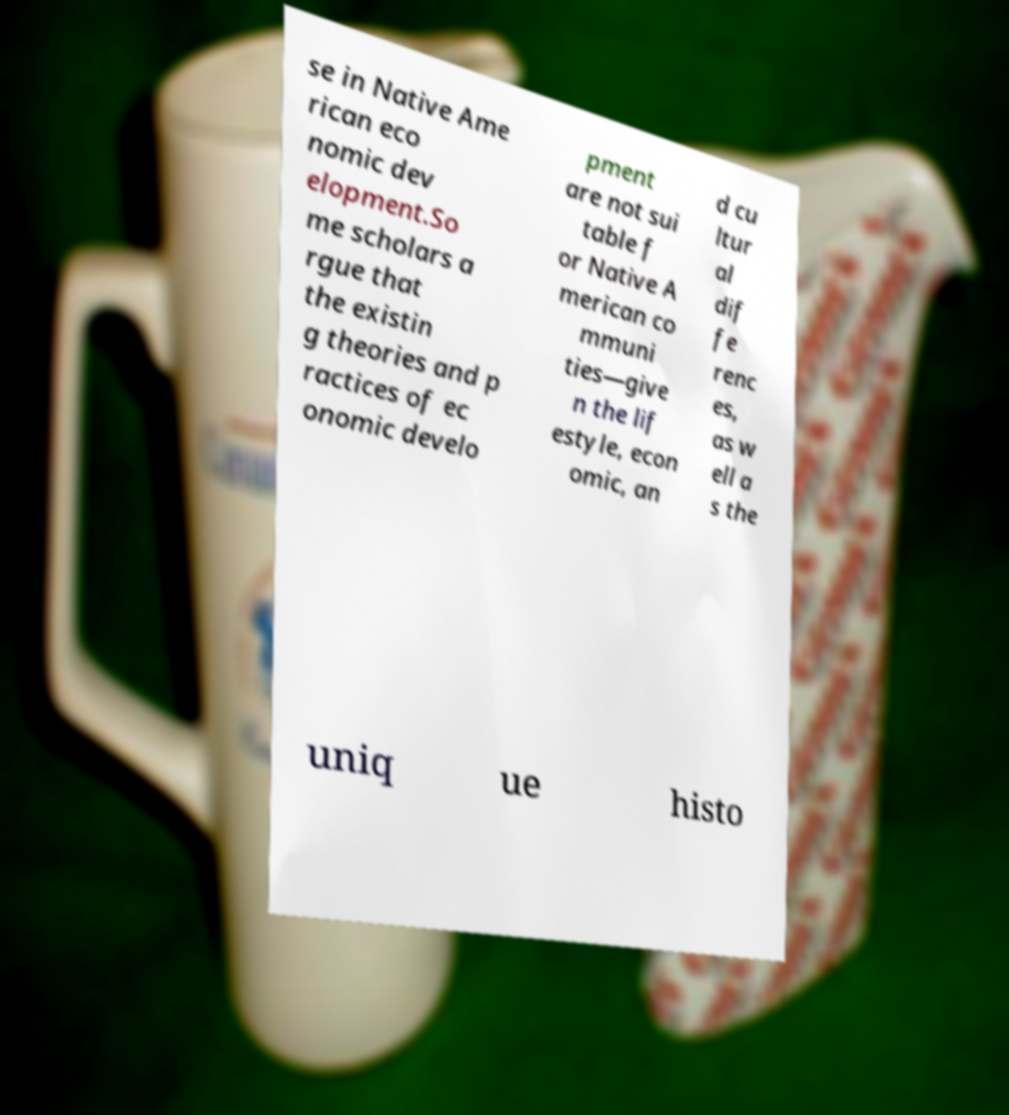Can you accurately transcribe the text from the provided image for me? se in Native Ame rican eco nomic dev elopment.So me scholars a rgue that the existin g theories and p ractices of ec onomic develo pment are not sui table f or Native A merican co mmuni ties—give n the lif estyle, econ omic, an d cu ltur al dif fe renc es, as w ell a s the uniq ue histo 